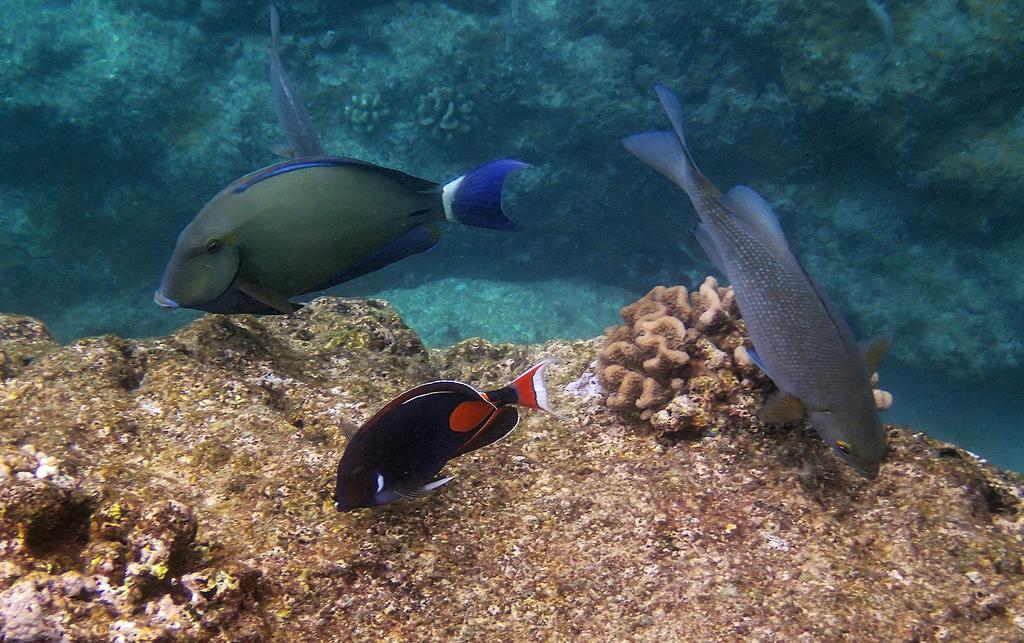In one or two sentences, can you explain what this image depicts? In this image we can see there are three fishes in the water and there are few sea plants. 